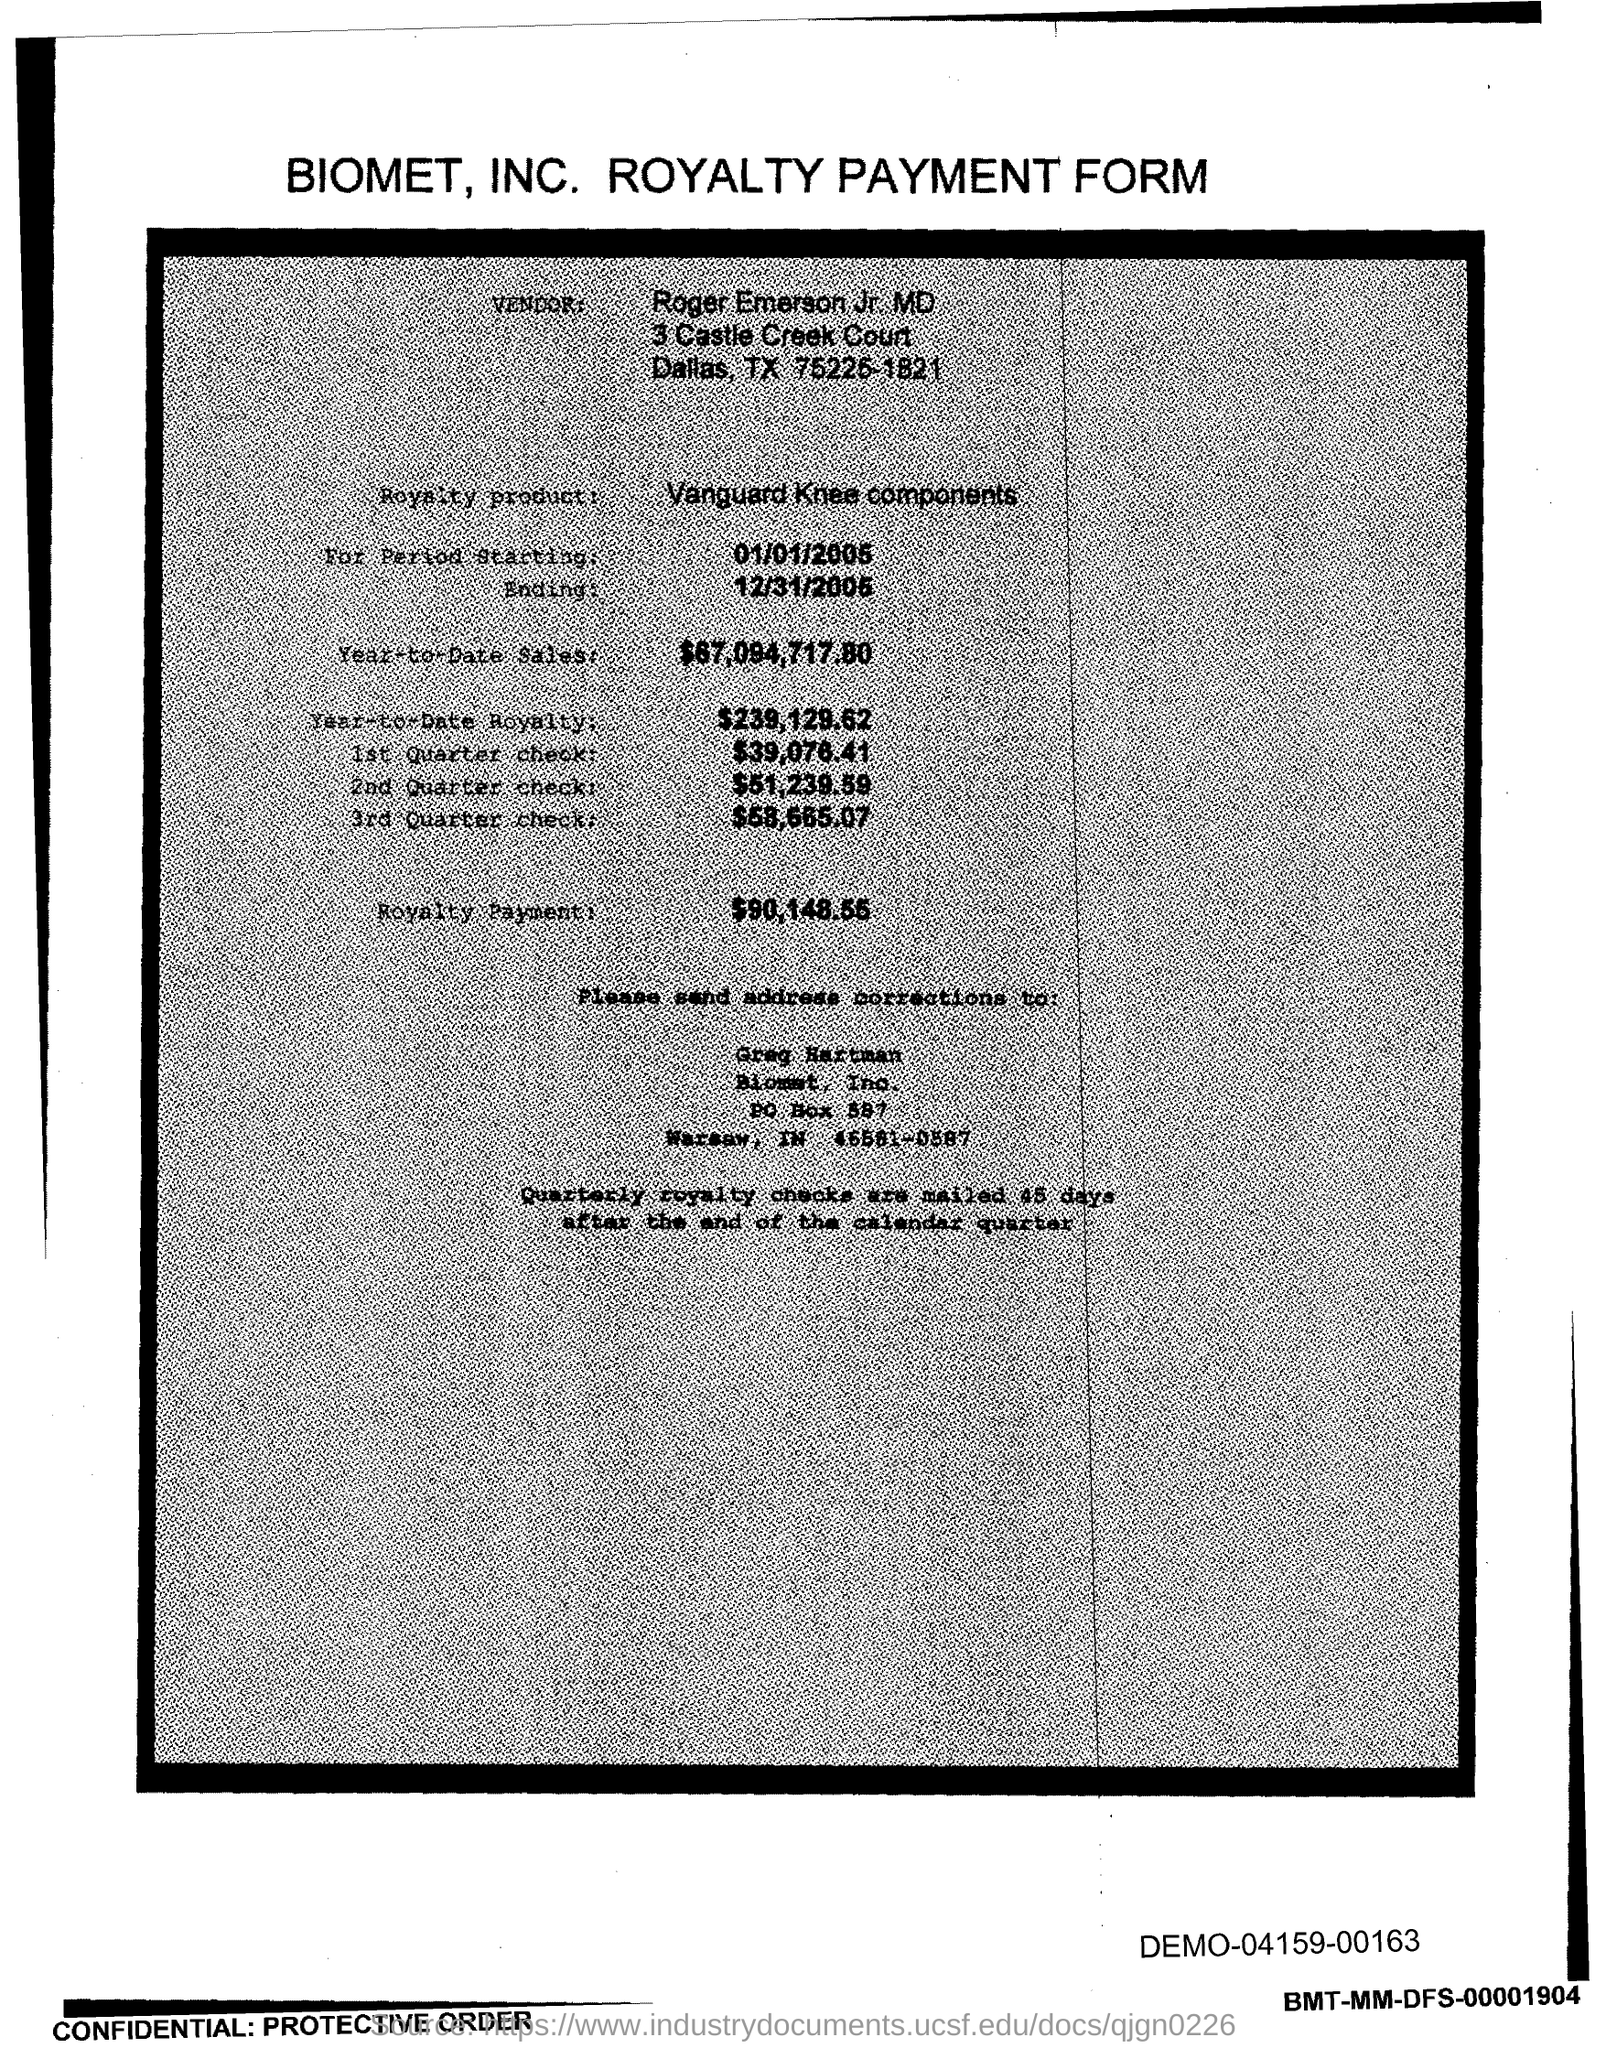Give some essential details in this illustration. The start date of the royalty period is January 1st, 2005. The royalty payment for the product mentioned in the form is $90,148.55. The year-to-date royalty for the product is $239,129.62. The amount of the 1st quarter check mentioned in the form is $39,076.41. The royalty product provided in the form is Vanguard Knee components. 